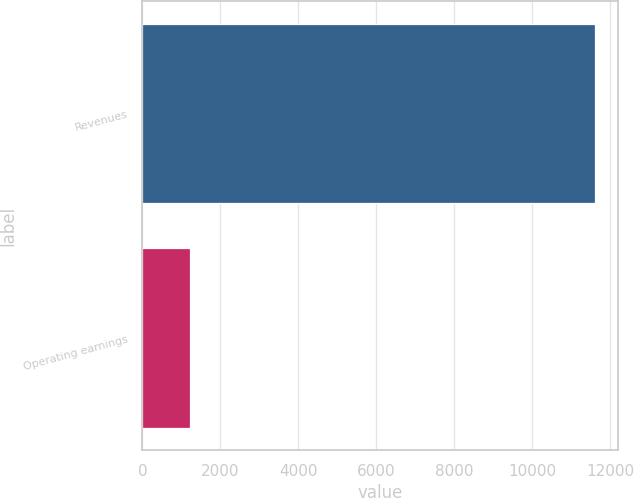<chart> <loc_0><loc_0><loc_500><loc_500><bar_chart><fcel>Revenues<fcel>Operating earnings<nl><fcel>11612<fcel>1219<nl></chart> 